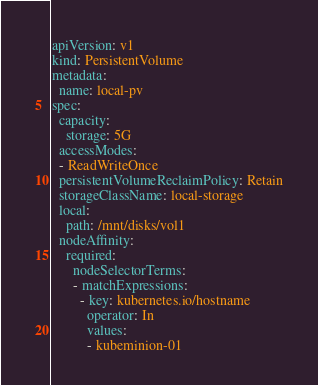Convert code to text. <code><loc_0><loc_0><loc_500><loc_500><_YAML_>apiVersion: v1
kind: PersistentVolume
metadata:
  name: local-pv
spec:
  capacity:
    storage: 5G
  accessModes:
  - ReadWriteOnce
  persistentVolumeReclaimPolicy: Retain
  storageClassName: local-storage
  local:
    path: /mnt/disks/vol1
  nodeAffinity:
    required:
      nodeSelectorTerms:
      - matchExpressions:
        - key: kubernetes.io/hostname
          operator: In
          values:
          - kubeminion-01 
</code> 